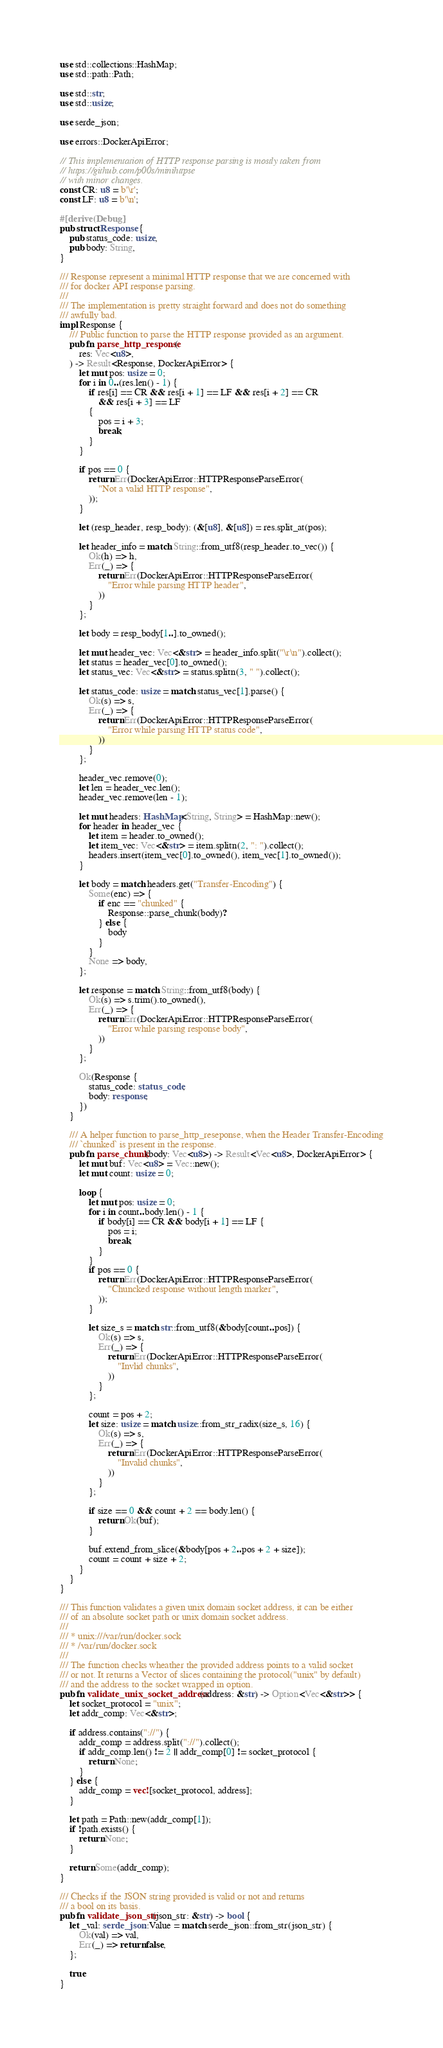Convert code to text. <code><loc_0><loc_0><loc_500><loc_500><_Rust_>use std::collections::HashMap;
use std::path::Path;

use std::str;
use std::usize;

use serde_json;

use errors::DockerApiError;

// This implementation of HTTP response parsing is mostly taken from
// https://github.com/p00s/minihttpse
// with minor changes.
const CR: u8 = b'\r';
const LF: u8 = b'\n';

#[derive(Debug)]
pub struct Response {
    pub status_code: usize,
    pub body: String,
}

/// Response represent a minimal HTTP response that we are concerned with
/// for docker API response parsing.
///
/// The implementation is pretty straight forward and does not do something
/// awfully bad.
impl Response {
    /// Public function to parse the HTTP response provided as an argument.
    pub fn parse_http_response(
        res: Vec<u8>,
    ) -> Result<Response, DockerApiError> {
        let mut pos: usize = 0;
        for i in 0..(res.len() - 1) {
            if res[i] == CR && res[i + 1] == LF && res[i + 2] == CR
                && res[i + 3] == LF
            {
                pos = i + 3;
                break;
            }
        }

        if pos == 0 {
            return Err(DockerApiError::HTTPResponseParseError(
                "Not a valid HTTP response",
            ));
        }

        let (resp_header, resp_body): (&[u8], &[u8]) = res.split_at(pos);

        let header_info = match String::from_utf8(resp_header.to_vec()) {
            Ok(h) => h,
            Err(_) => {
                return Err(DockerApiError::HTTPResponseParseError(
                    "Error while parsing HTTP header",
                ))
            }
        };

        let body = resp_body[1..].to_owned();

        let mut header_vec: Vec<&str> = header_info.split("\r\n").collect();
        let status = header_vec[0].to_owned();
        let status_vec: Vec<&str> = status.splitn(3, " ").collect();

        let status_code: usize = match status_vec[1].parse() {
            Ok(s) => s,
            Err(_) => {
                return Err(DockerApiError::HTTPResponseParseError(
                    "Error while parsing HTTP status code",
                ))
            }
        };

        header_vec.remove(0);
        let len = header_vec.len();
        header_vec.remove(len - 1);

        let mut headers: HashMap<String, String> = HashMap::new();
        for header in header_vec {
            let item = header.to_owned();
            let item_vec: Vec<&str> = item.splitn(2, ": ").collect();
            headers.insert(item_vec[0].to_owned(), item_vec[1].to_owned());
        }

        let body = match headers.get("Transfer-Encoding") {
            Some(enc) => {
                if enc == "chunked" {
                    Response::parse_chunk(body)?
                } else {
                    body
                }
            }
            None => body,
        };

        let response = match String::from_utf8(body) {
            Ok(s) => s.trim().to_owned(),
            Err(_) => {
                return Err(DockerApiError::HTTPResponseParseError(
                    "Error while parsing response body",
                ))
            }
        };

        Ok(Response {
            status_code: status_code,
            body: response,
        })
    }

    /// A helper function to parse_http_reseponse, when the Header Transfer-Encoding
    /// `chunked` is present in the response.
    pub fn parse_chunk(body: Vec<u8>) -> Result<Vec<u8>, DockerApiError> {
        let mut buf: Vec<u8> = Vec::new();
        let mut count: usize = 0;

        loop {
            let mut pos: usize = 0;
            for i in count..body.len() - 1 {
                if body[i] == CR && body[i + 1] == LF {
                    pos = i;
                    break;
                }
            }
            if pos == 0 {
                return Err(DockerApiError::HTTPResponseParseError(
                    "Chuncked response without length marker",
                ));
            }

            let size_s = match str::from_utf8(&body[count..pos]) {
                Ok(s) => s,
                Err(_) => {
                    return Err(DockerApiError::HTTPResponseParseError(
                        "Invlid chunks",
                    ))
                }
            };

            count = pos + 2;
            let size: usize = match usize::from_str_radix(size_s, 16) {
                Ok(s) => s,
                Err(_) => {
                    return Err(DockerApiError::HTTPResponseParseError(
                        "Invalid chunks",
                    ))
                }
            };

            if size == 0 && count + 2 == body.len() {
                return Ok(buf);
            }

            buf.extend_from_slice(&body[pos + 2..pos + 2 + size]);
            count = count + size + 2;
        }
    }
}

/// This function validates a given unix domain socket address, it can be either
/// of an absolute socket path or unix domain socket address.
///
/// * unix:///var/run/docker.sock
/// * /var/run/docker.sock
///
/// The function checks wheather the provided address points to a valid socket
/// or not. It returns a Vector of slices containing the protocol("unix" by default)
/// and the address to the socket wrapped in option.
pub fn validate_unix_socket_address(address: &str) -> Option<Vec<&str>> {
    let socket_protocol = "unix";
    let addr_comp: Vec<&str>;

    if address.contains("://") {
        addr_comp = address.split("://").collect();
        if addr_comp.len() != 2 || addr_comp[0] != socket_protocol {
            return None;
        }
    } else {
        addr_comp = vec![socket_protocol, address];
    }

    let path = Path::new(addr_comp[1]);
    if !path.exists() {
        return None;
    }

    return Some(addr_comp);
}

/// Checks if the JSON string provided is valid or not and returns
/// a bool on its basis.
pub fn validate_json_str(json_str: &str) -> bool {
    let _val: serde_json::Value = match serde_json::from_str(json_str) {
        Ok(val) => val,
        Err(_) => return false,
    };

    true
}
</code> 